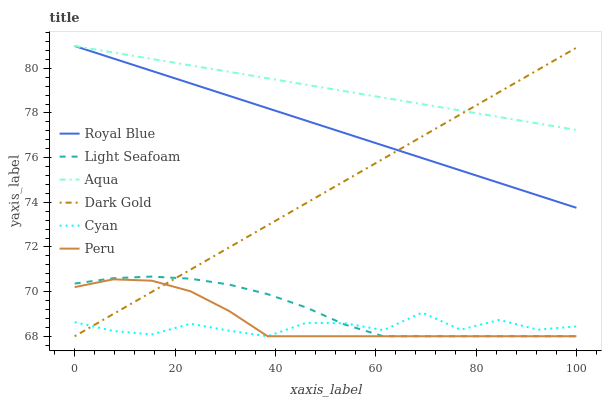Does Royal Blue have the minimum area under the curve?
Answer yes or no. No. Does Royal Blue have the maximum area under the curve?
Answer yes or no. No. Is Royal Blue the smoothest?
Answer yes or no. No. Is Royal Blue the roughest?
Answer yes or no. No. Does Royal Blue have the lowest value?
Answer yes or no. No. Does Peru have the highest value?
Answer yes or no. No. Is Cyan less than Royal Blue?
Answer yes or no. Yes. Is Royal Blue greater than Cyan?
Answer yes or no. Yes. Does Cyan intersect Royal Blue?
Answer yes or no. No. 